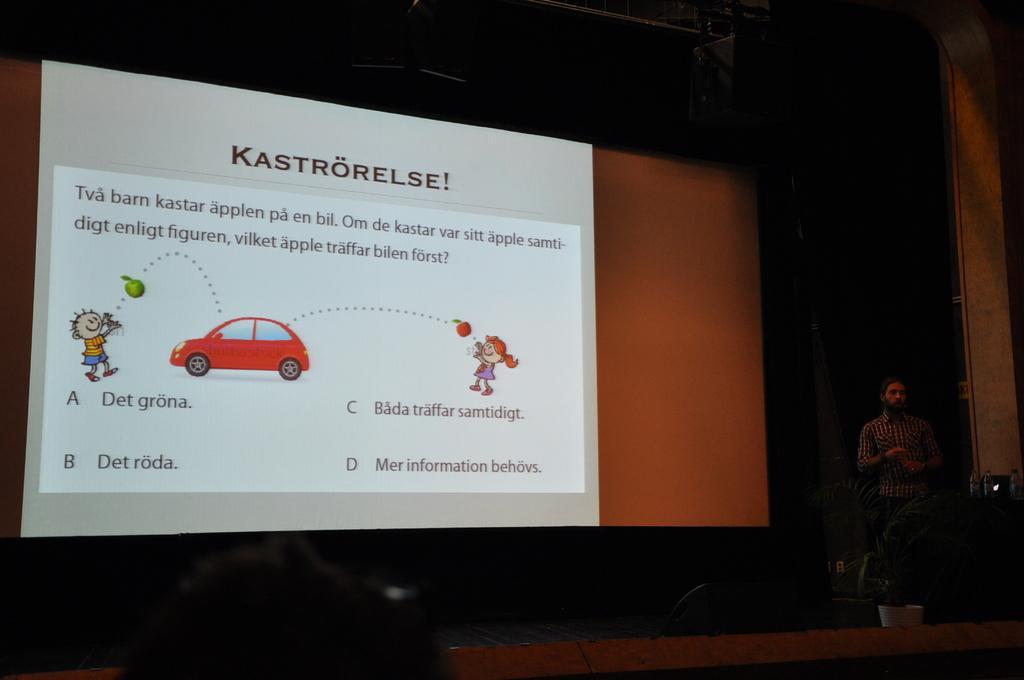Please provide a concise description of this image. On the right side of the image we can see a person standing on the stage, plant in a pot, bottles and a laptop. In the foreground we can see a person. In the background, we can see a speaker, screen with pictures and text. 